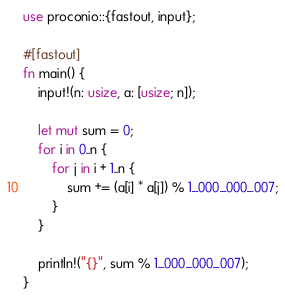Convert code to text. <code><loc_0><loc_0><loc_500><loc_500><_Rust_>use proconio::{fastout, input};

#[fastout]
fn main() {
    input!(n: usize, a: [usize; n]);

    let mut sum = 0;
    for i in 0..n {
        for j in i + 1..n {
            sum += (a[i] * a[j]) % 1_000_000_007;
        }
    }

    println!("{}", sum % 1_000_000_007);
}
</code> 